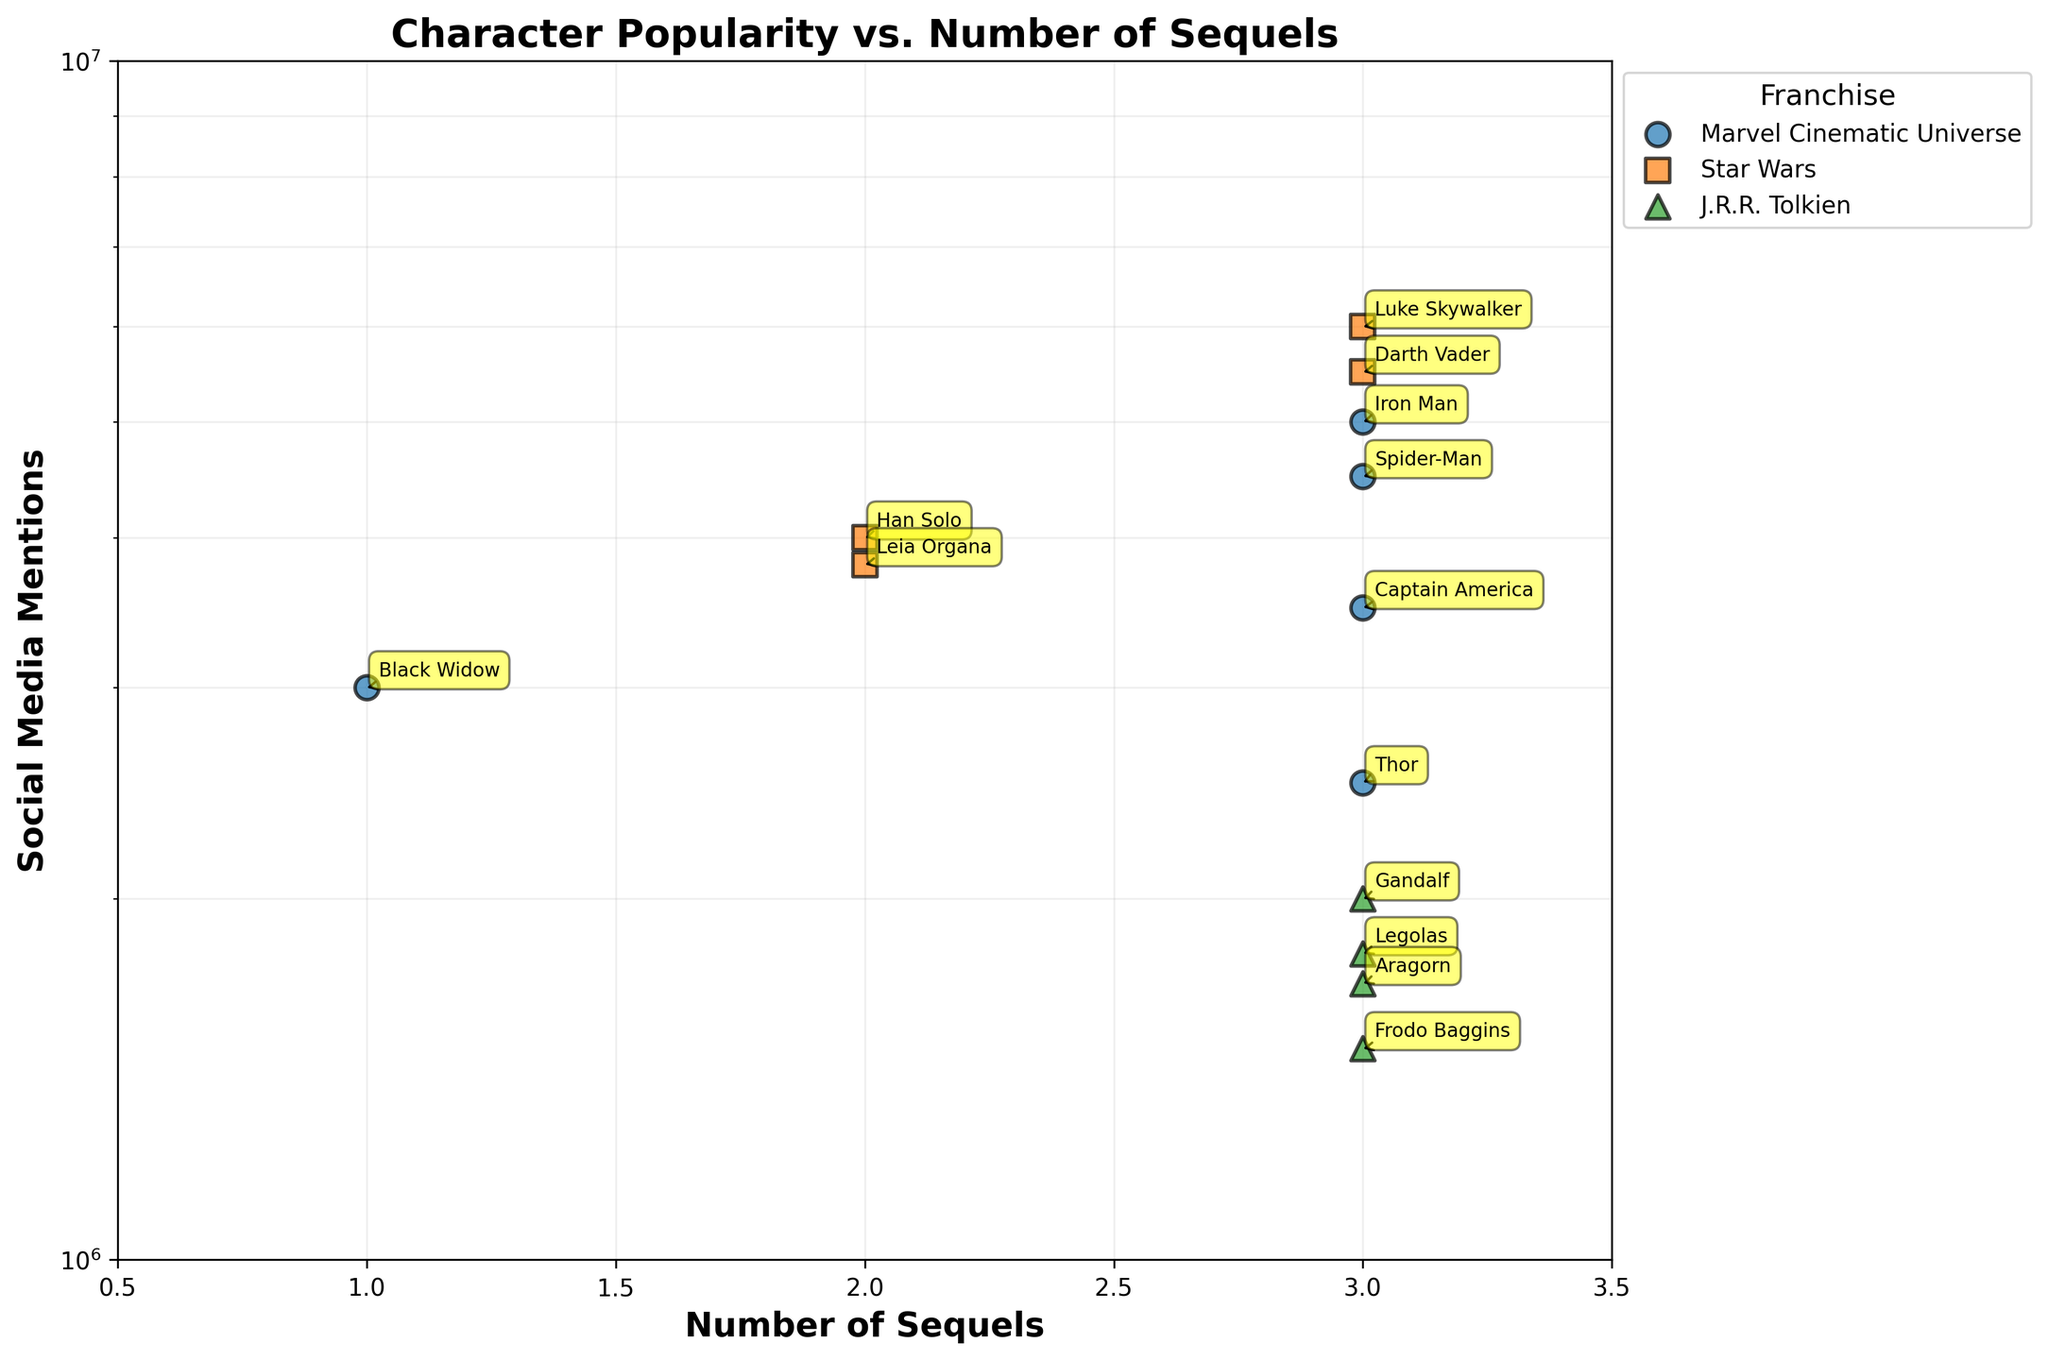What is the title of the plot? The title of the plot is usually prominently displayed at the top of the figure. In this case, the title is "Character Popularity vs. Number of Sequels" as shown in the provided code.
Answer: Character Popularity vs. Number of Sequels How many Marvel Cinematic Universe characters are shown in the plot? The plot distinguishes different franchises through colors and markers. By counting the markers with the color corresponding to "Marvel Cinematic Universe", we find Iron Man, Captain America, Thor, Spider-Man, and Black Widow. There are 5 such characters.
Answer: 5 Which character has the highest number of social media mentions? To find this character, we look at the highest point on the y-axis, which is "Luke Skywalker" from Star Wars with 6,000,000 mentions.
Answer: Luke Skywalker How does the number of sequels relate to social media mentions for Marvel Cinematic Universe characters? Observing points for Marvel characters (identifiable by their color and marker), we see that despite the same number of sequels (3 for all), Iron Man and Spider-Man have higher mentions than Captain America and Thor, showing varying popularity despite an equal number of sequels.
Answer: Varies What is the median number of social media mentions for Star Wars characters? List social media mentions for Star Wars (6,000,000, 5,500,000, 4,000,000, 3,800,000), and find the median value. As the data set has an even number of entries, the median is the average of the two middle numbers: (5,500,000 + 4,000,000) / 2 = 4,750,000.
Answer: 4,750,000 Which J.R.R. Tolkien character has the most social media mentions? By identifying points with the triangular marker and green color, and comparing their y-values, Gandalf has the highest value with 2,000,000 mentions.
Answer: Gandalf Compare social media mentions of "Leia Organa" and "Legolas". Which one is higher? Locate "Leia Organa" and "Legolas" on the scatter plot and compare their y-values. "Leia Organa" has 3,800,000 mentions, whereas "Legolas" has 1,800,000 mentions. Thus, "Leia Organa" has higher mentions.
Answer: Leia Organa What can you infer about the visibility of "Black Widow" compared to other Marvel characters? "Black Widow" has less social media mentions (3,000,000) despite her appearance in only one sequel, suggesting her overall popularity is lower compared to other Marvel characters like Iron Man and Spider-Man who have similar or higher mentions with more sequels.
Answer: Lower popularity Does any character from Star Wars have fewer than 2 sequels? If yes, who? By examining the x-axis values for Star Wars-coded points, no character has fewer than 2 sequels. All Star Wars characters in the plot have 2 or more sequels.
Answer: No Which character has the lowest dot position on the y-axis from all three franchises? This character will be at the lowest y-value in the scatter plot. "Frodo Baggins" from J.R.R. Tolkien franchise has the lowest position with 1,500,000 social media mentions.
Answer: Frodo Baggins 